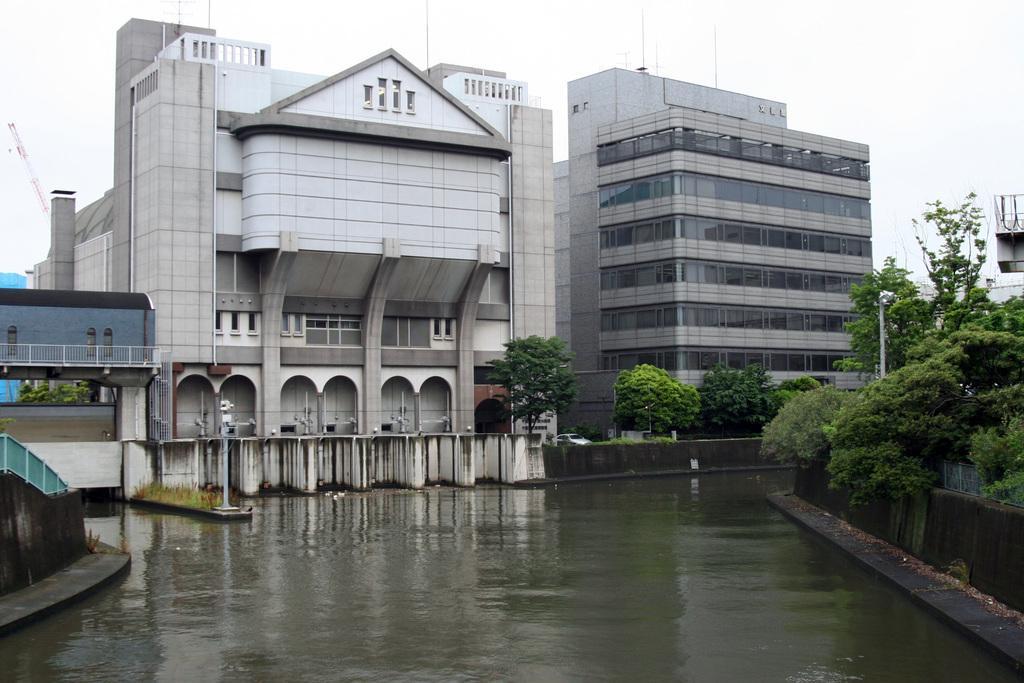Please provide a concise description of this image. There are plants and water surface in the foreground area of the image, there are buildings, poles, trees and the sky in the background. 